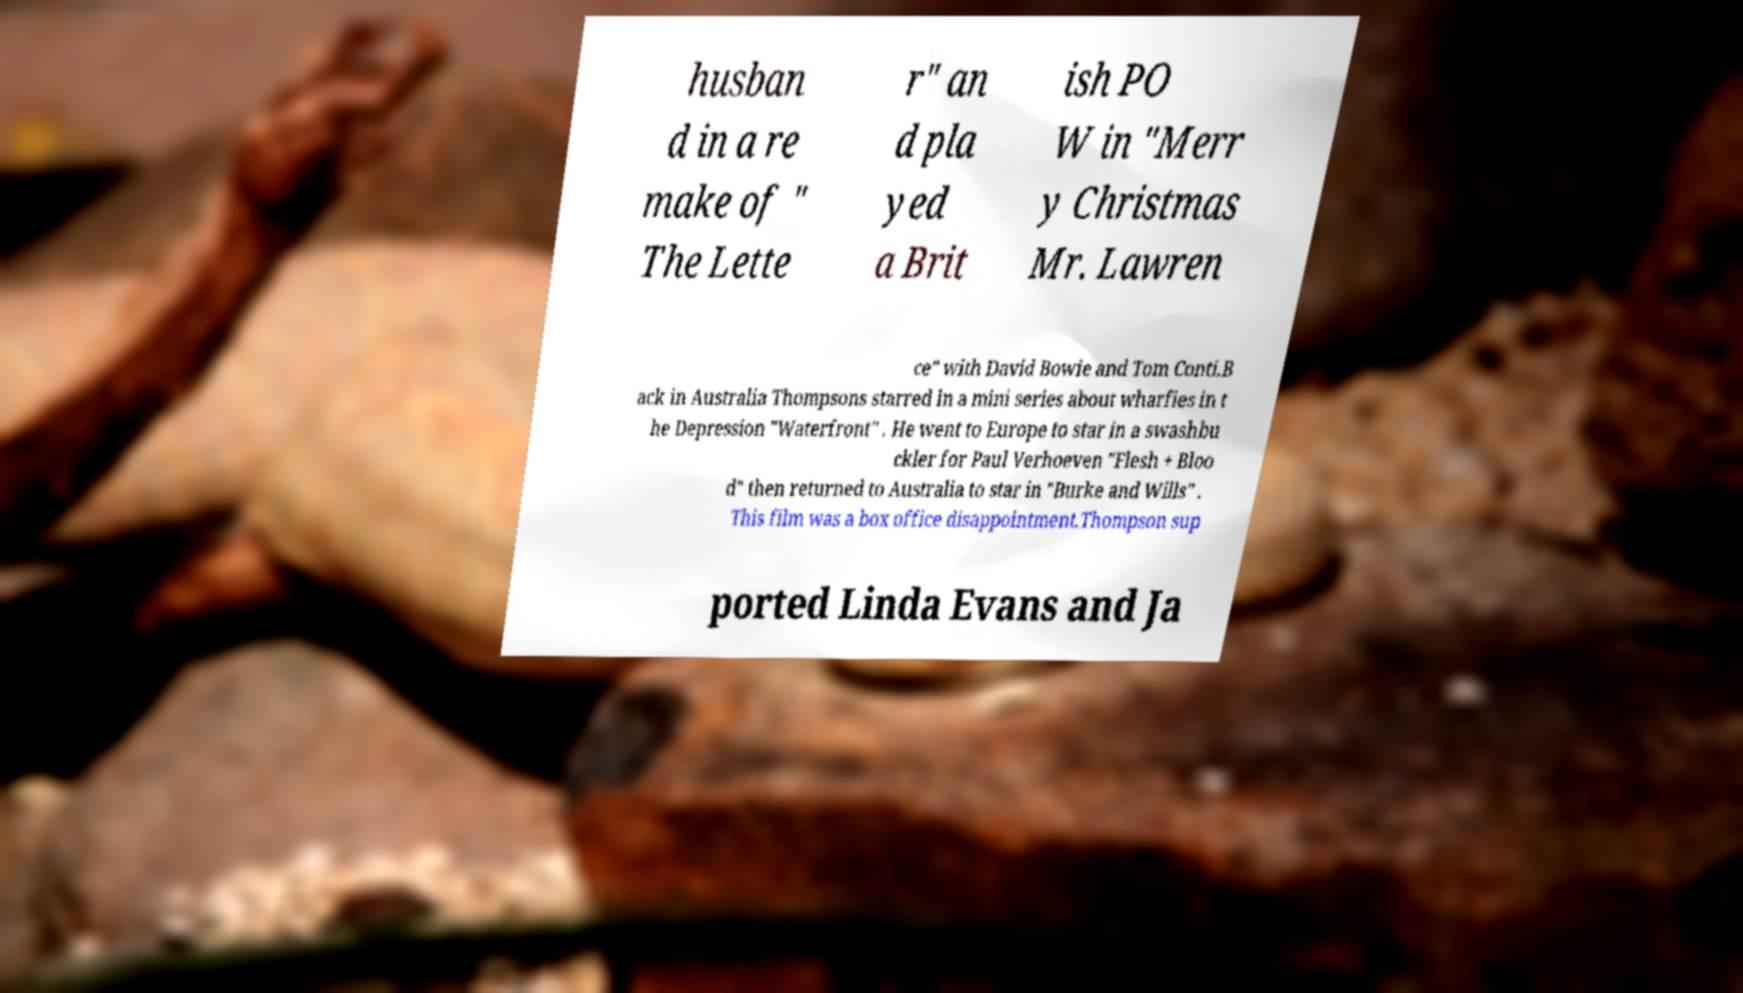For documentation purposes, I need the text within this image transcribed. Could you provide that? husban d in a re make of " The Lette r" an d pla yed a Brit ish PO W in "Merr y Christmas Mr. Lawren ce" with David Bowie and Tom Conti.B ack in Australia Thompsons starred in a mini series about wharfies in t he Depression "Waterfront" . He went to Europe to star in a swashbu ckler for Paul Verhoeven "Flesh + Bloo d" then returned to Australia to star in "Burke and Wills" . This film was a box office disappointment.Thompson sup ported Linda Evans and Ja 